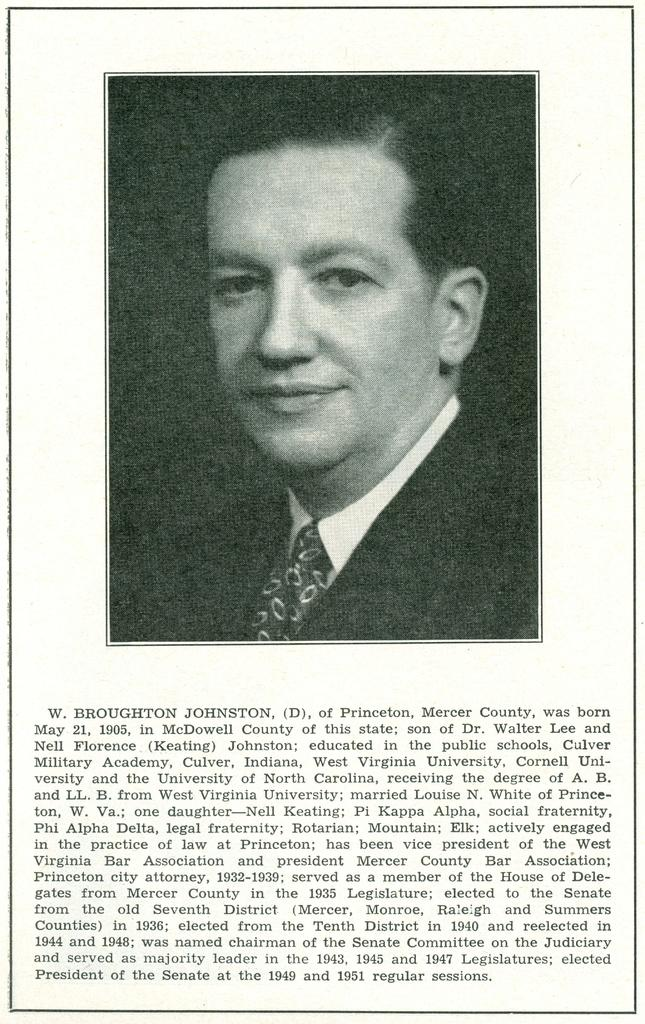What is the main subject of the image? The main subject of the image is a person's photo. Are there any other elements in the image besides the photo? Yes, there is text in the image. What type of object might the image be a part of? The image appears to be a photo frame. Can you see any bats flying around in the image? No, there are no bats visible in the image. Is there a clam shell in the photo frame? There is no mention of a clam shell in the image or the photo frame. 